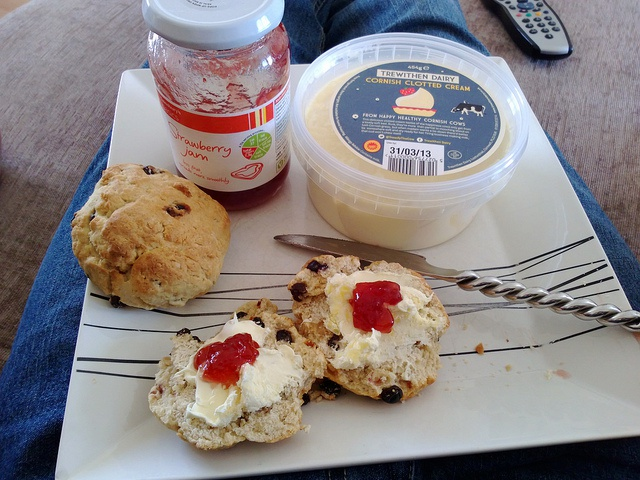Describe the objects in this image and their specific colors. I can see bottle in darkgray, gray, lightblue, and lavender tones, people in darkgray, navy, black, darkblue, and blue tones, knife in darkgray, maroon, gray, and black tones, and remote in darkgray, black, and gray tones in this image. 